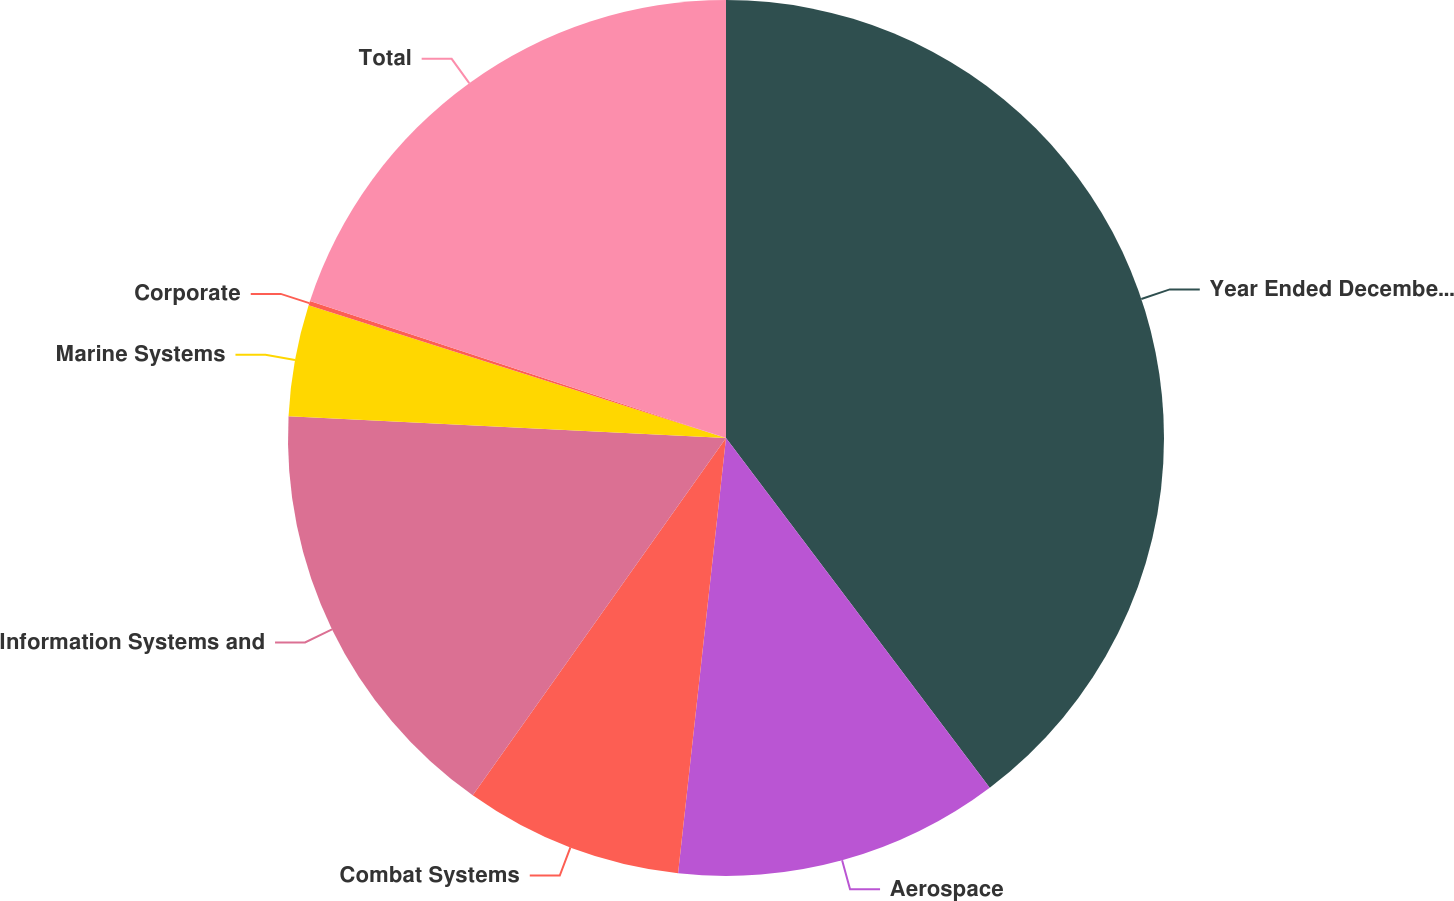Convert chart to OTSL. <chart><loc_0><loc_0><loc_500><loc_500><pie_chart><fcel>Year Ended December 31<fcel>Aerospace<fcel>Combat Systems<fcel>Information Systems and<fcel>Marine Systems<fcel>Corporate<fcel>Total<nl><fcel>39.72%<fcel>12.03%<fcel>8.07%<fcel>15.98%<fcel>4.11%<fcel>0.16%<fcel>19.94%<nl></chart> 